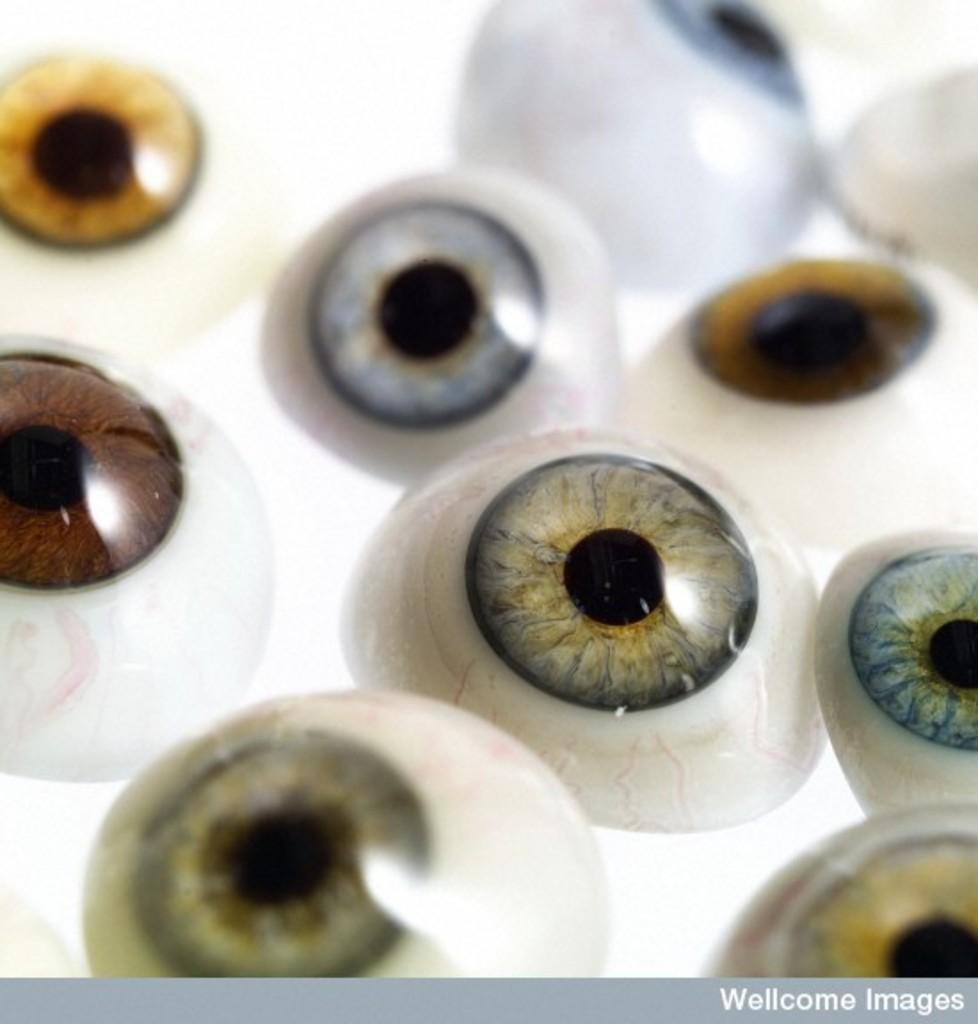What is the main subject of the image? The main subject of the image is many eyeballs. Is there any text or border present in the image? Yes, there is a border with text at the bottom of the image. What type of lace is being used by the geese in the image? There are no geese or lace present in the image. 